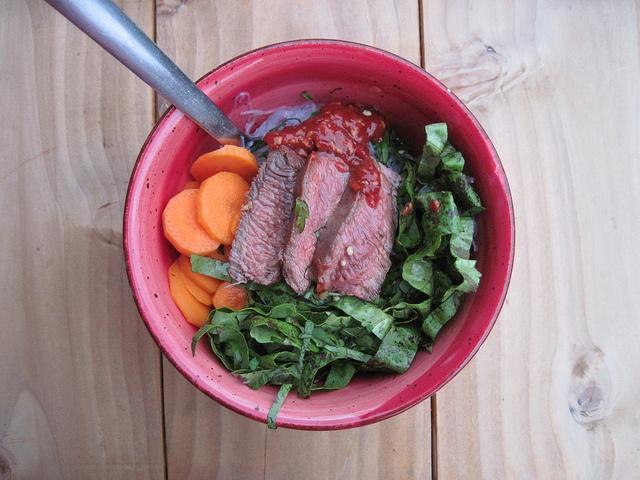Is this a healthy meal?
Keep it brief. Yes. What color is the bowl?
Write a very short answer. Red. Is this ready to eat?
Answer briefly. Yes. 